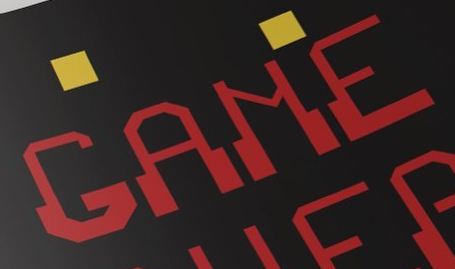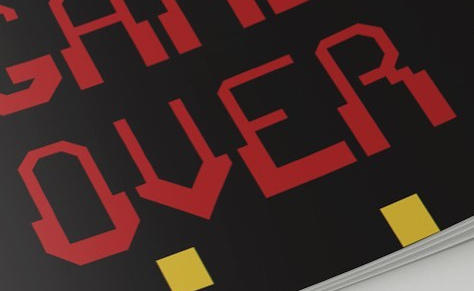Identify the words shown in these images in order, separated by a semicolon. GAME; OVER 